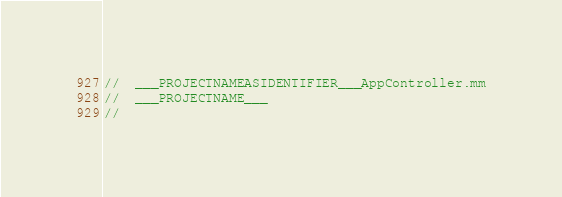Convert code to text. <code><loc_0><loc_0><loc_500><loc_500><_ObjectiveC_>//  ___PROJECTNAMEASIDENTIFIER___AppController.mm
//  ___PROJECTNAME___
//</code> 